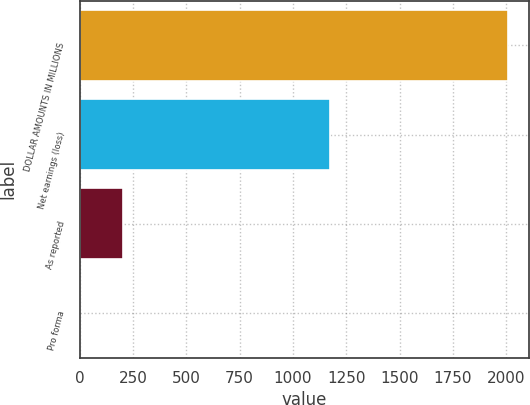Convert chart. <chart><loc_0><loc_0><loc_500><loc_500><bar_chart><fcel>DOLLAR AMOUNTS IN MILLIONS<fcel>Net earnings (loss)<fcel>As reported<fcel>Pro forma<nl><fcel>2008<fcel>1176<fcel>202.78<fcel>2.2<nl></chart> 